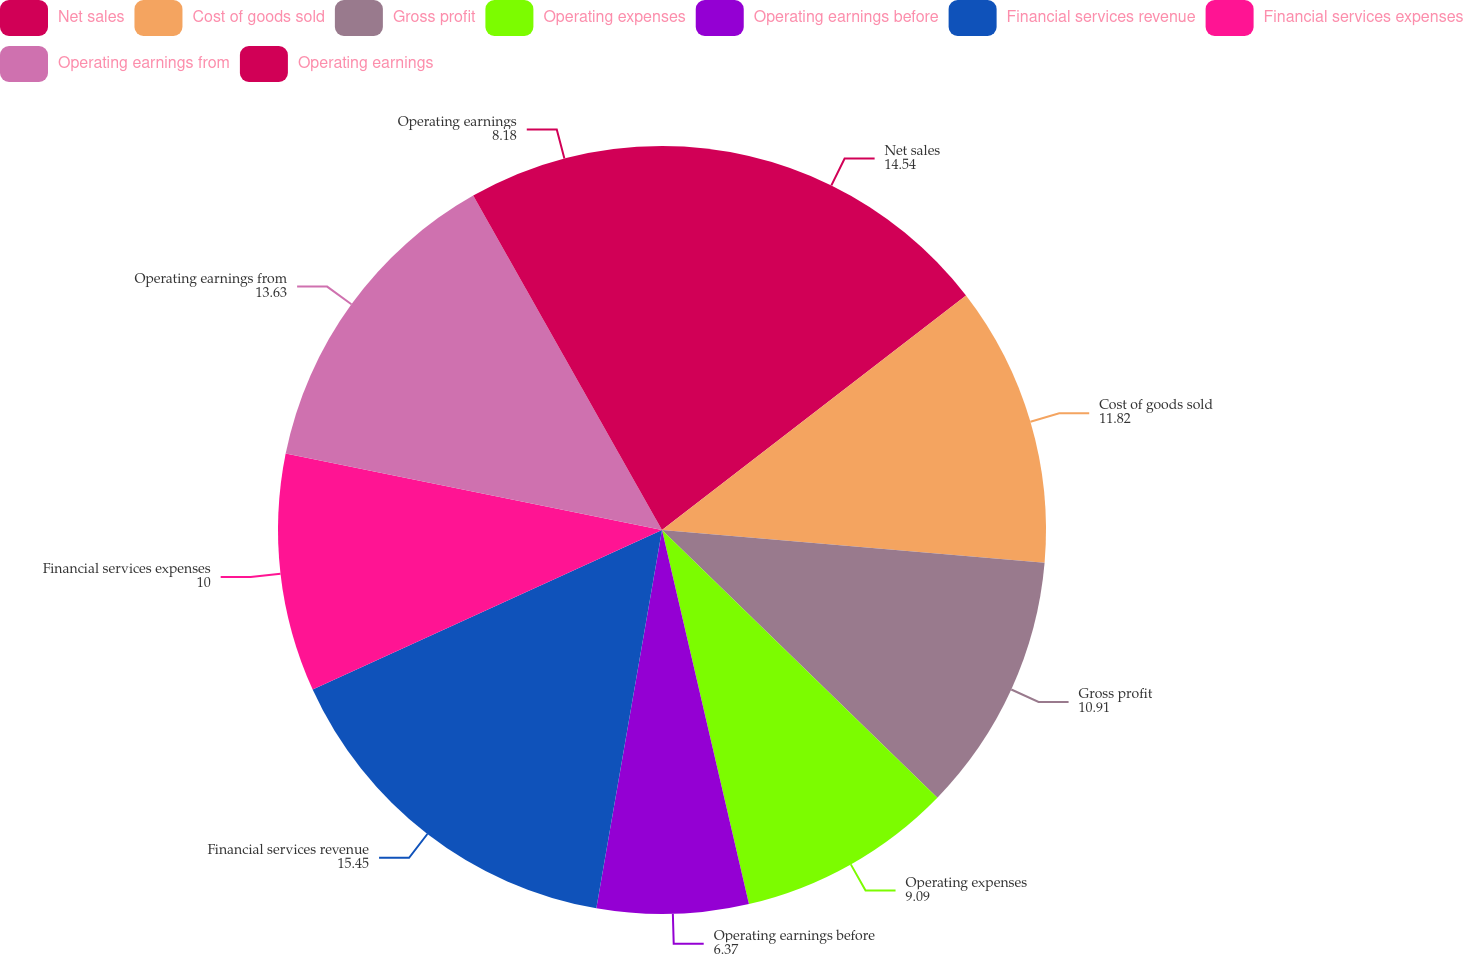<chart> <loc_0><loc_0><loc_500><loc_500><pie_chart><fcel>Net sales<fcel>Cost of goods sold<fcel>Gross profit<fcel>Operating expenses<fcel>Operating earnings before<fcel>Financial services revenue<fcel>Financial services expenses<fcel>Operating earnings from<fcel>Operating earnings<nl><fcel>14.54%<fcel>11.82%<fcel>10.91%<fcel>9.09%<fcel>6.37%<fcel>15.45%<fcel>10.0%<fcel>13.63%<fcel>8.18%<nl></chart> 